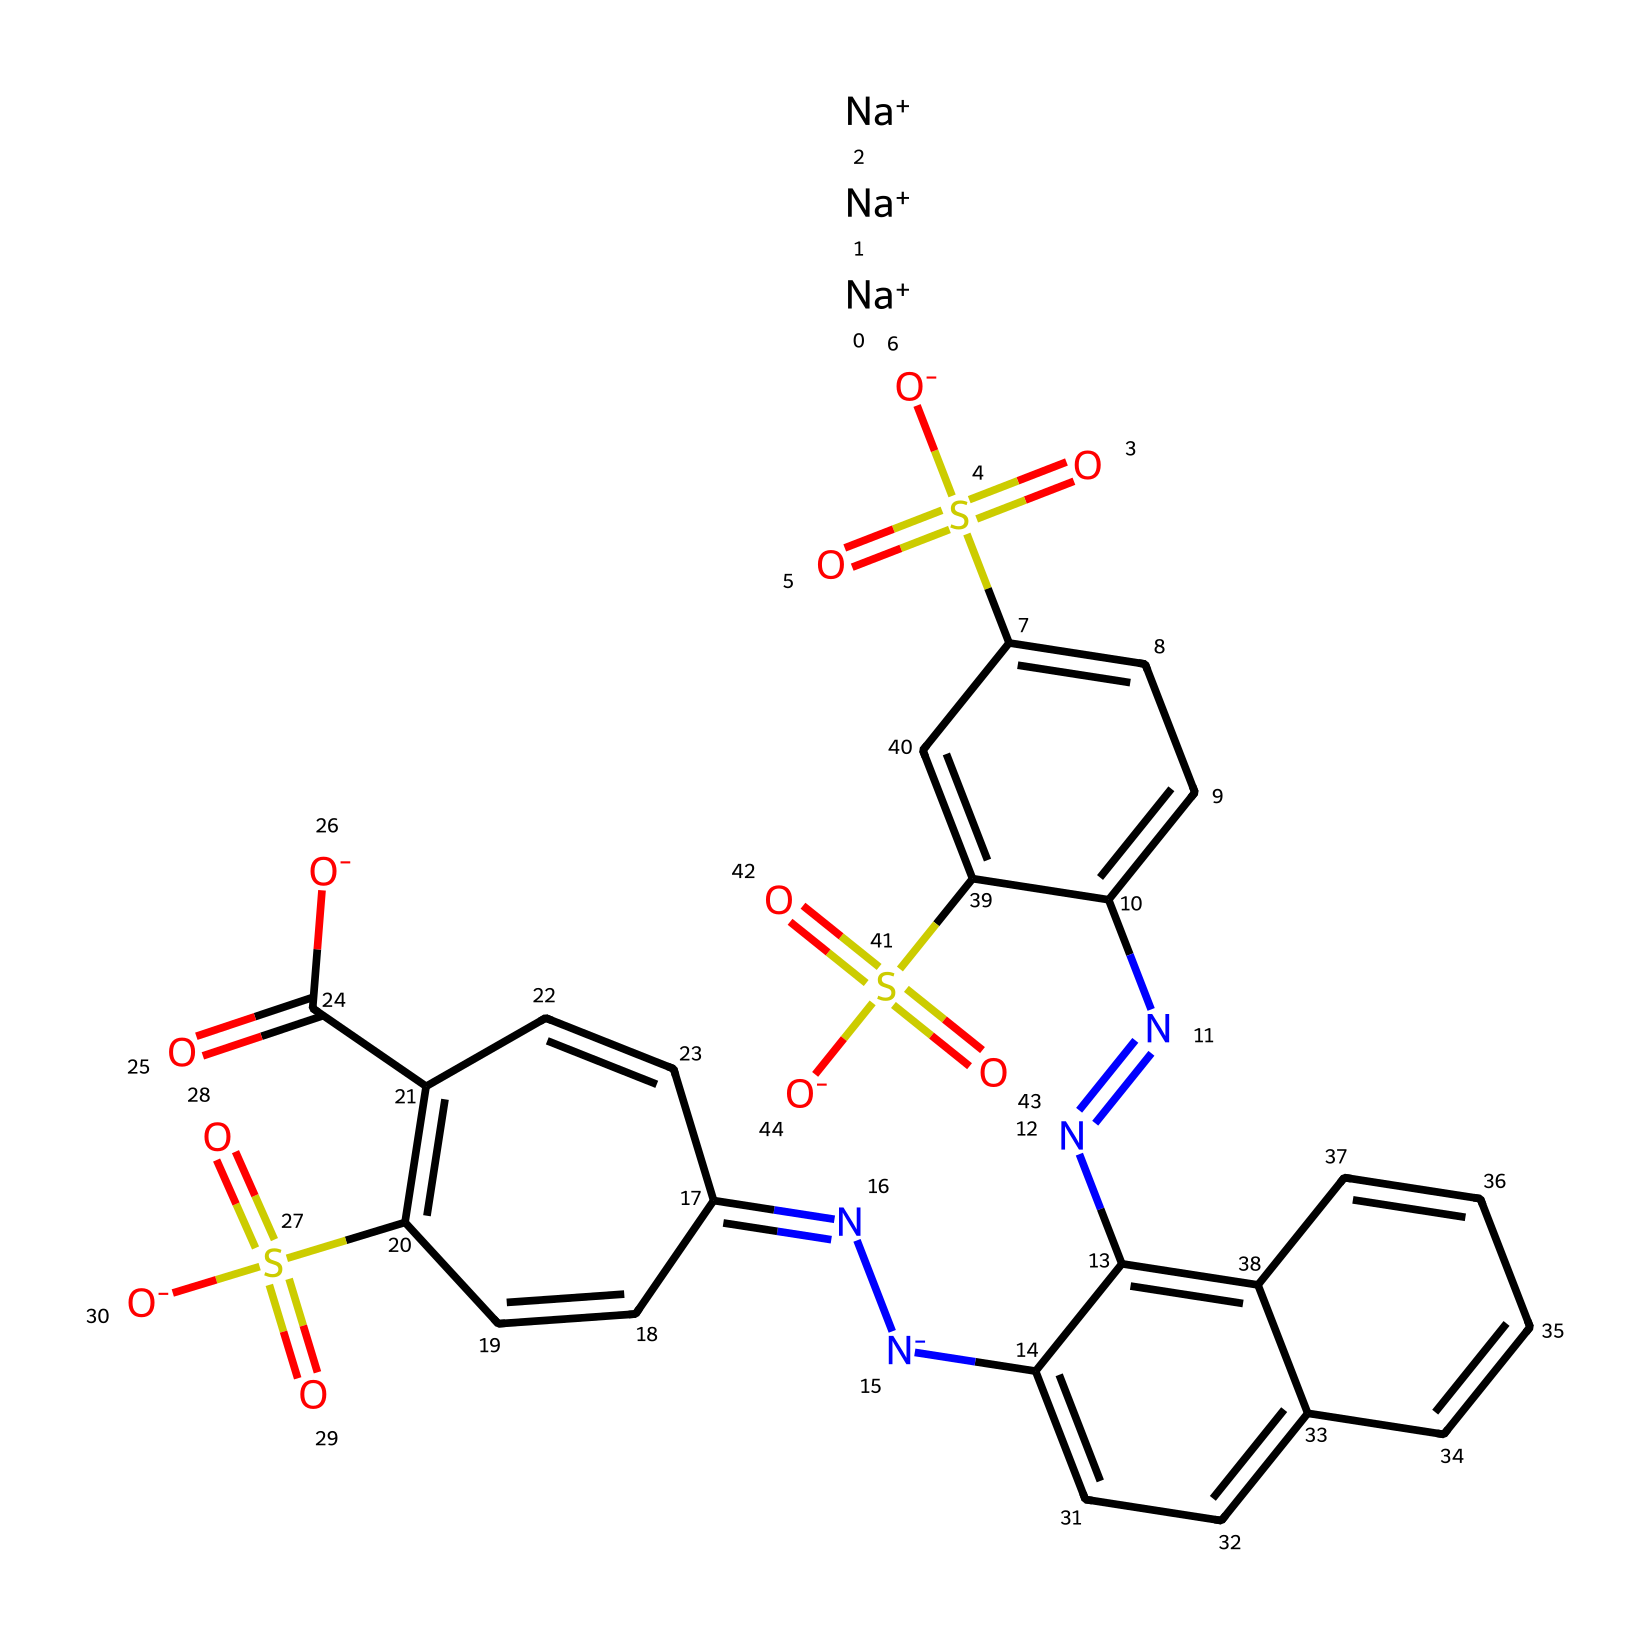What is the primary color of tartrazine? The chemical structure of tartrazine is designed to produce a synthetic yellow color.
Answer: yellow How many nitrogen atoms are present in the tartrazine structure? By counting the nitrogen atoms in the provided SMILES representation, there are a total of three nitrogen atoms based on the 'N' character.
Answer: 3 What type of chemical is tartrazine classified as? Tartrazine is classified as a synthetic food dye, specifically a food additive used to impart color to foods.
Answer: synthetic food dye How many sodium ions are associated with tartrazine? The SMILES representation includes '[Na+]' three times, which means there are three sodium ions present.
Answer: 3 What functional group is indicated by the "-SO3-" notation in the SMILES? The notation denotes the sulfonic acid functional group (-SO3), which is typically involved in the solubility and stability of the dye.
Answer: sulfonic acid Does tartrazine contain aromatic rings in its structure? The presence of 'c' in the SMILES indicates that there are aromatic carbon atoms, showing that tartrazine contains aromatic rings.
Answer: yes What effect does the chemical arrangement of tartrazine have on its solubility? The sulfonic acid groups increase the solubility of tartrazine in aqueous solutions, making it suitable for food applications.
Answer: increases solubility 